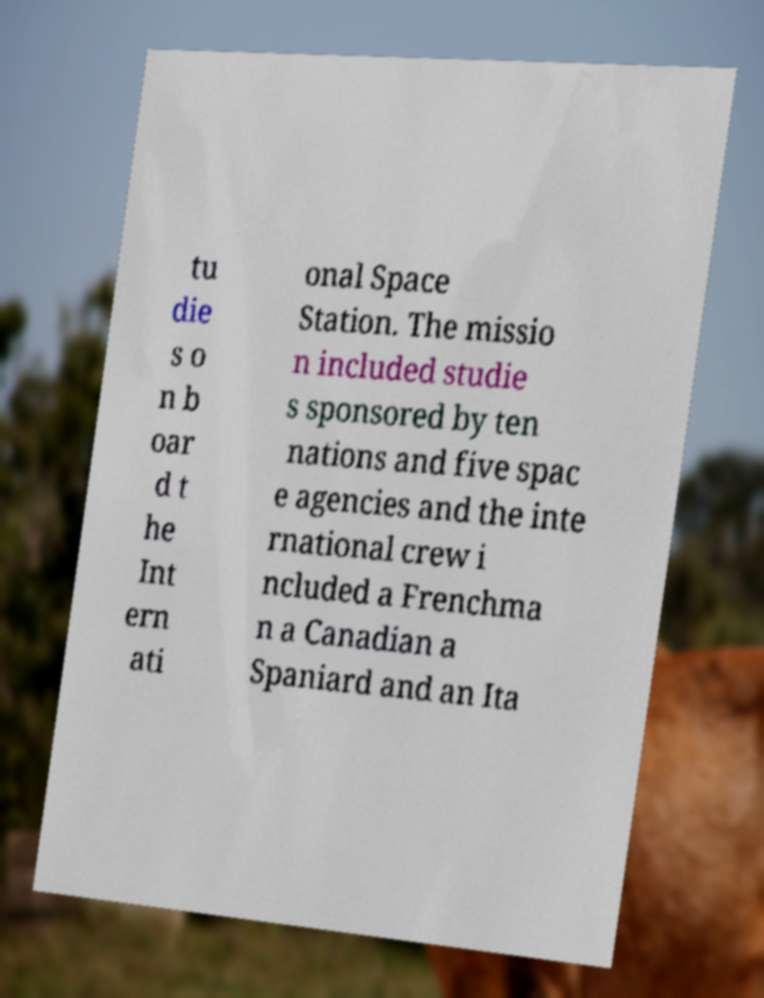Can you accurately transcribe the text from the provided image for me? tu die s o n b oar d t he Int ern ati onal Space Station. The missio n included studie s sponsored by ten nations and five spac e agencies and the inte rnational crew i ncluded a Frenchma n a Canadian a Spaniard and an Ita 